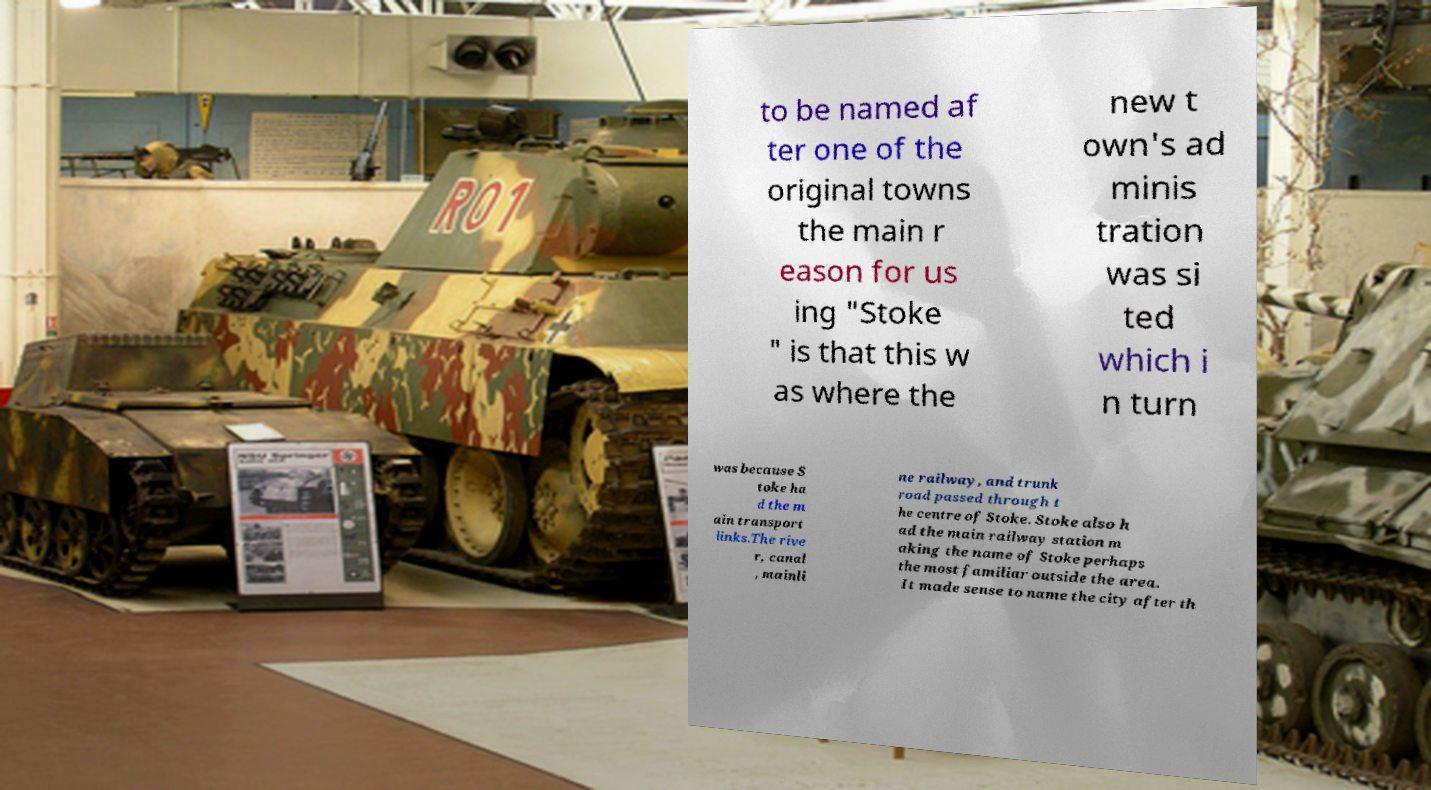Please read and relay the text visible in this image. What does it say? to be named af ter one of the original towns the main r eason for us ing "Stoke " is that this w as where the new t own's ad minis tration was si ted which i n turn was because S toke ha d the m ain transport links.The rive r, canal , mainli ne railway, and trunk road passed through t he centre of Stoke. Stoke also h ad the main railway station m aking the name of Stoke perhaps the most familiar outside the area. It made sense to name the city after th 